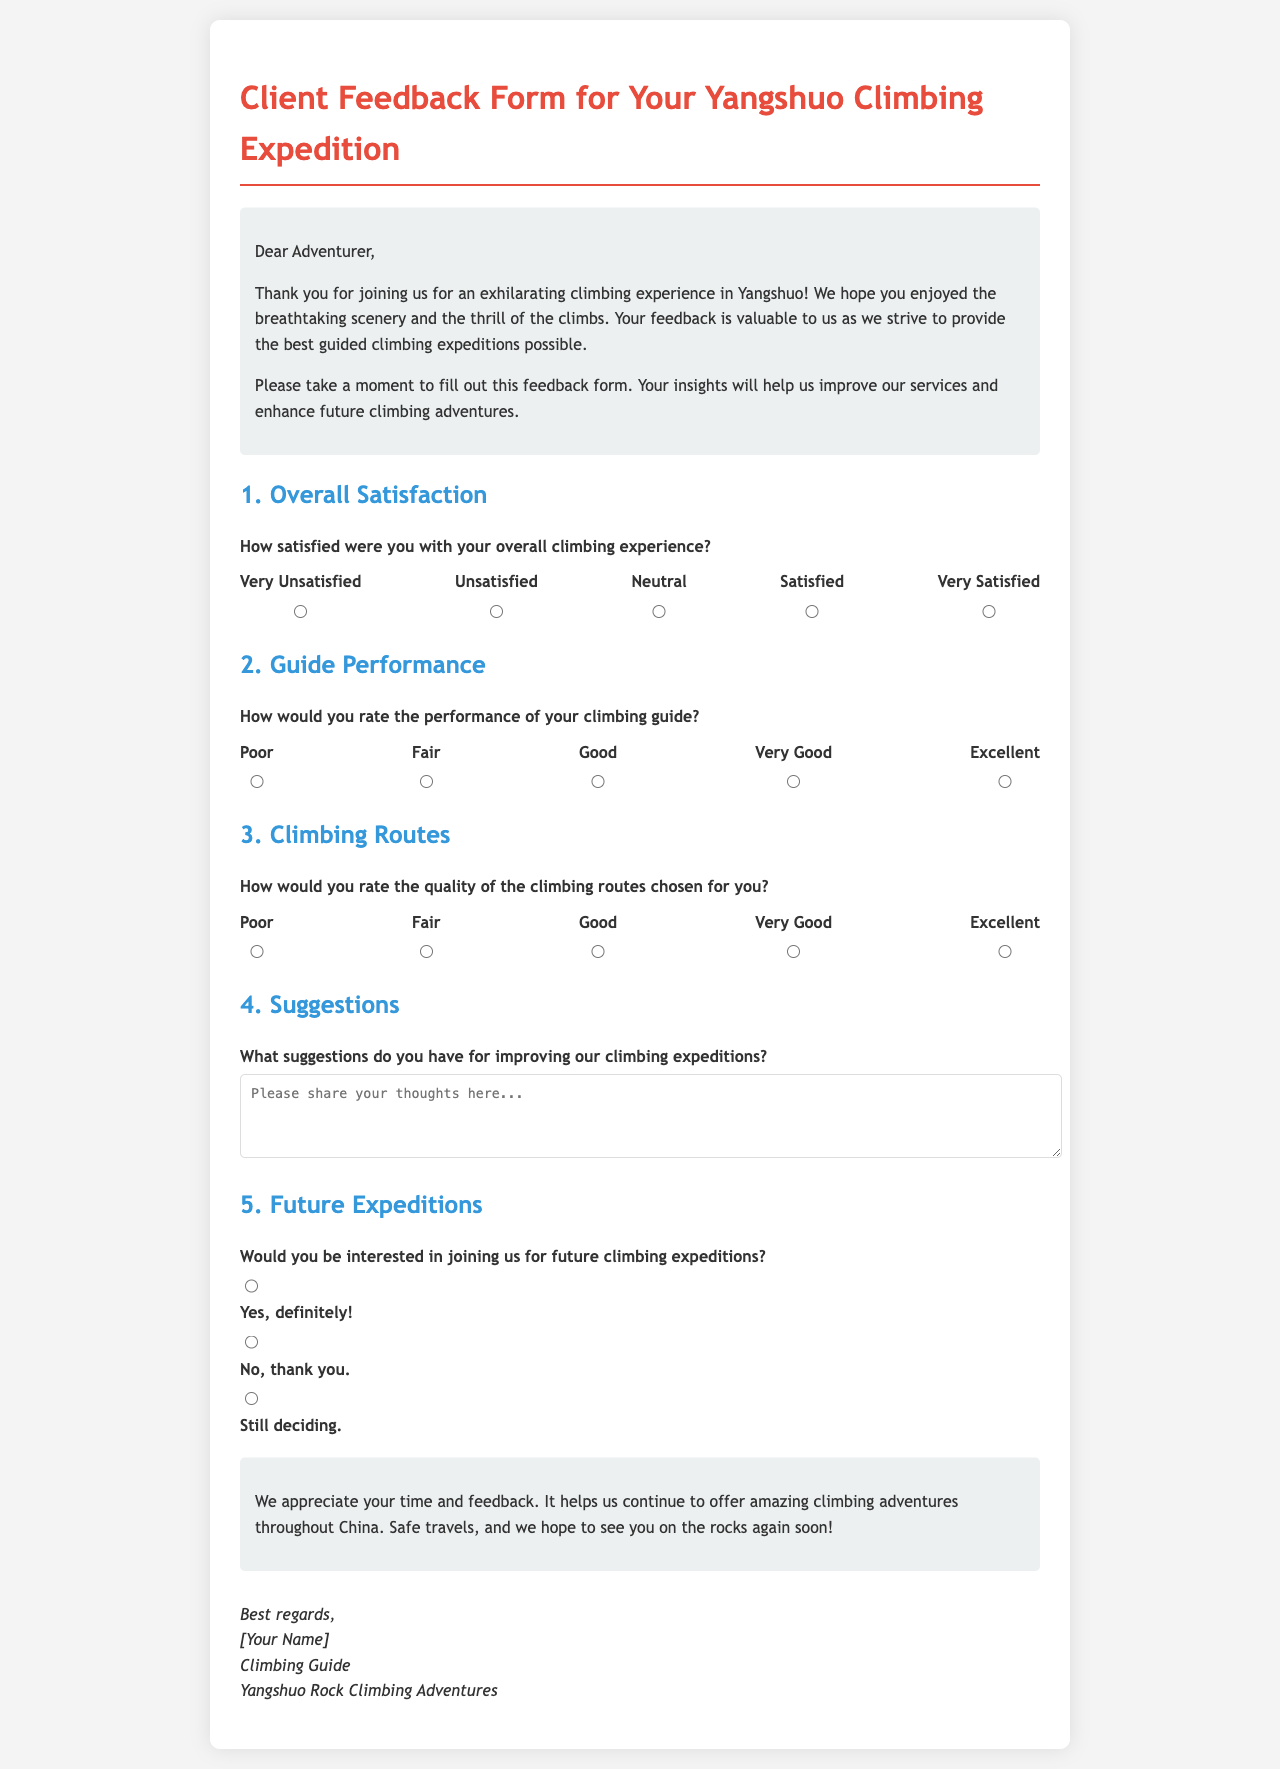What is the title of the document? The title is indicated in the header section of the document.
Answer: Client Feedback Form for Your Yangshuo Climbing Expedition What is the main purpose of this document? The purpose is stated in the introduction section, highlighting the feedback request for climbers.
Answer: To gather client feedback How many rating options are provided for overall satisfaction? The document lists the rating options under the Overall Satisfaction section.
Answer: Five What is the highest rating for the guide's performance? The guide's performance rating scale is mentioned in the respective section of the form.
Answer: Excellent What type of suggestions is requested from clients? The document specifically asks for suggestions to improve climbing expeditions.
Answer: Suggestions for improving expeditions What are the three options given for future expeditions? The options are listed under the Future Expeditions section for client feedback.
Answer: Yes, definitely!; No, thank you.; Still deciding Which section would you find information about the quality of climbing routes? The section title indicates that it addresses specific aspects about climbing routes.
Answer: Climbing Routes What is the closing message's tone? The tone can be inferred from the words used in the closing section of the document.
Answer: Appreciative Who is signing off the document? The signature section reveals the identity of the person concluding the document.
Answer: [Your Name] 